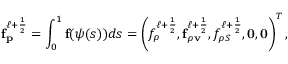<formula> <loc_0><loc_0><loc_500><loc_500>f _ { p } ^ { \ell + \frac { 1 } { 2 } } = \int _ { 0 } ^ { 1 } f ( \psi ( s ) ) d s = \left ( f _ { \rho } ^ { \ell + \frac { 1 } { 2 } } , f _ { \rho v } ^ { \ell + \frac { 1 } { 2 } } , f _ { \rho S } ^ { \ell + \frac { 1 } { 2 } } , 0 , 0 \right ) ^ { T } ,</formula> 